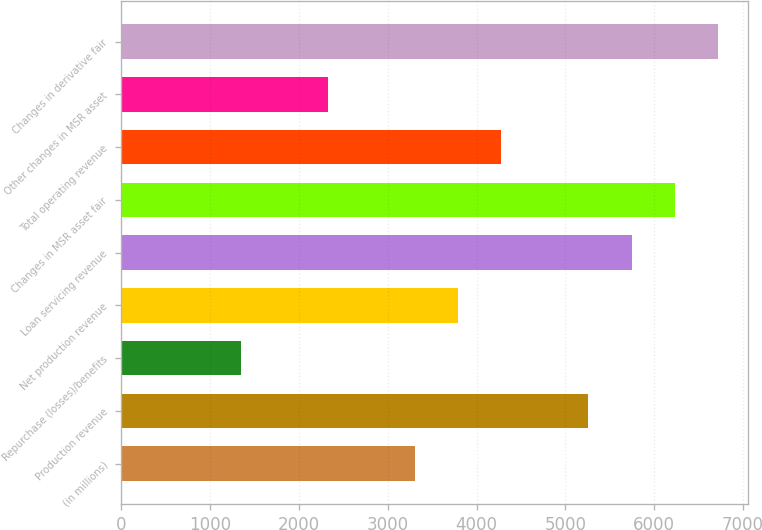Convert chart to OTSL. <chart><loc_0><loc_0><loc_500><loc_500><bar_chart><fcel>(in millions)<fcel>Production revenue<fcel>Repurchase (losses)/benefits<fcel>Net production revenue<fcel>Loan servicing revenue<fcel>Changes in MSR asset fair<fcel>Total operating revenue<fcel>Other changes in MSR asset<fcel>Changes in derivative fair<nl><fcel>3301.8<fcel>5256.6<fcel>1347<fcel>3790.5<fcel>5745.3<fcel>6234<fcel>4279.2<fcel>2324.4<fcel>6722.7<nl></chart> 